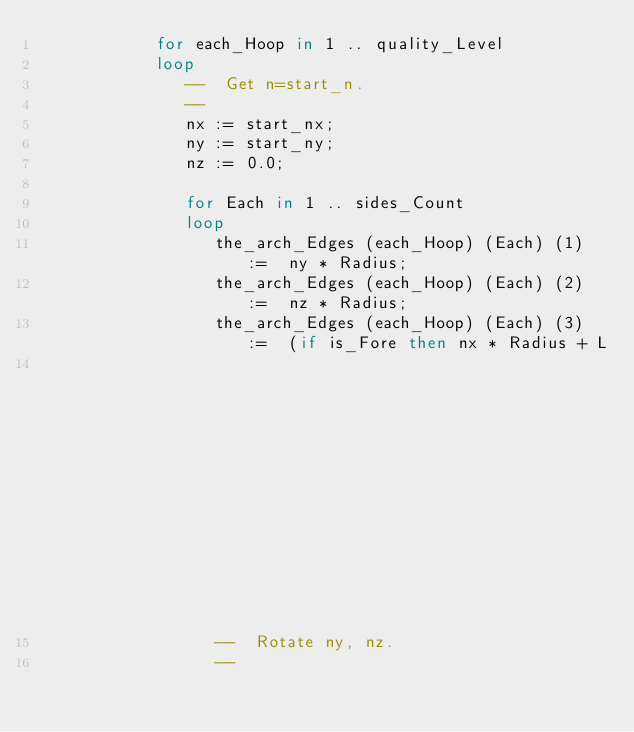Convert code to text. <code><loc_0><loc_0><loc_500><loc_500><_Ada_>            for each_Hoop in 1 .. quality_Level
            loop
               --  Get n=start_n.
               --
               nx := start_nx;
               ny := start_ny;
               nz := 0.0;

               for Each in 1 .. sides_Count
               loop
                  the_arch_Edges (each_Hoop) (Each) (1) :=  ny * Radius;
                  the_arch_Edges (each_Hoop) (Each) (2) :=  nz * Radius;
                  the_arch_Edges (each_Hoop) (Each) (3) :=  (if is_Fore then nx * Radius + L
                                                                        else nx * Radius - L);
                  --  Rotate ny, nz.
                  --</code> 